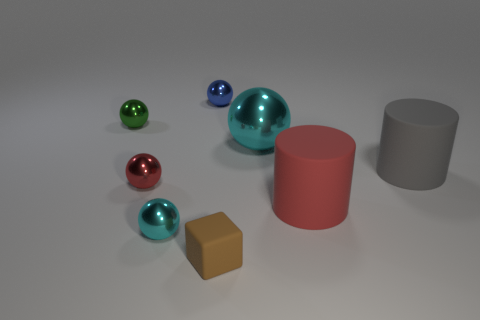Subtract all purple spheres. Subtract all green cylinders. How many spheres are left? 5 Add 2 gray things. How many objects exist? 10 Subtract all cubes. How many objects are left? 7 Add 4 tiny blocks. How many tiny blocks exist? 5 Subtract 0 purple spheres. How many objects are left? 8 Subtract all rubber cylinders. Subtract all small red metallic balls. How many objects are left? 5 Add 5 large red cylinders. How many large red cylinders are left? 6 